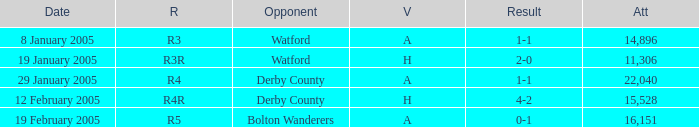What is the round of the game at venue H and opponent of Derby County? R4R. 